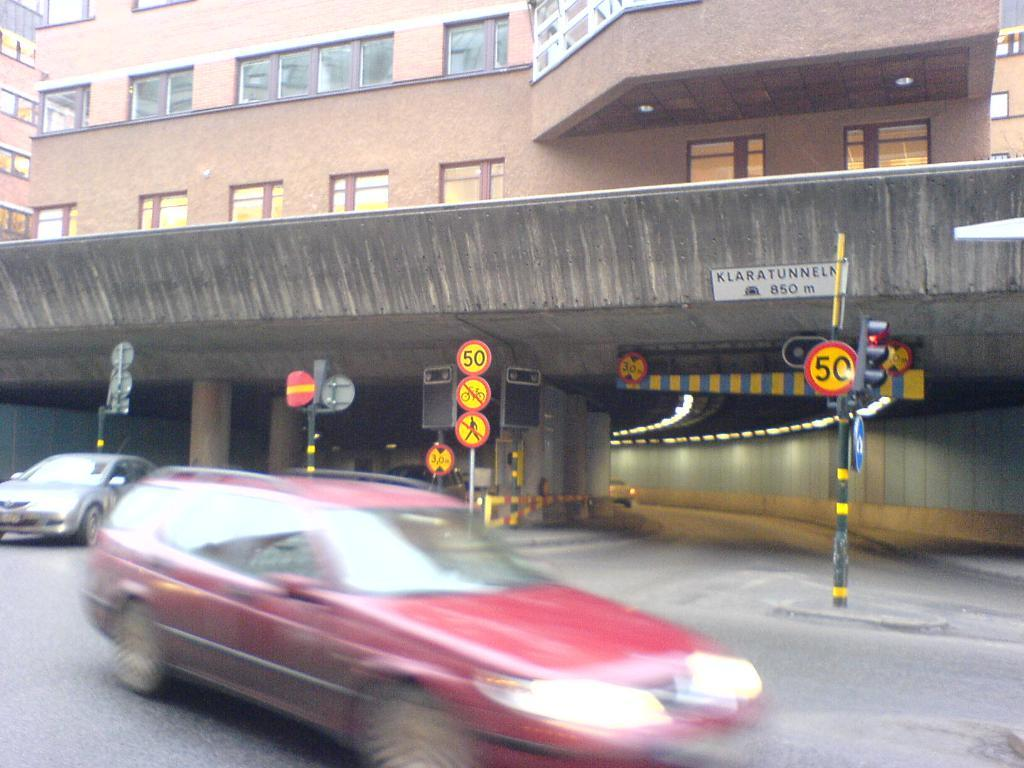<image>
Offer a succinct explanation of the picture presented. the sign with the number 50 on it 